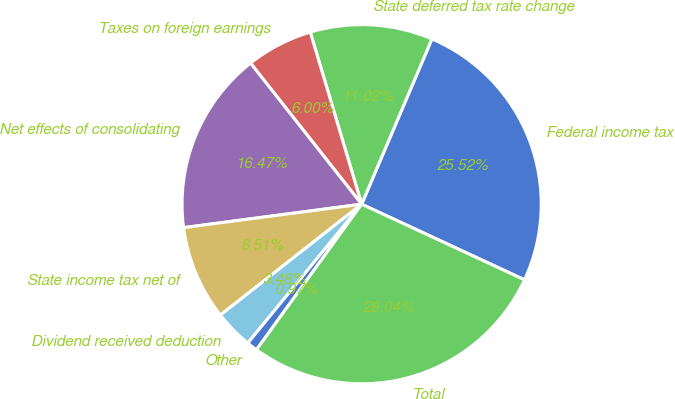Convert chart to OTSL. <chart><loc_0><loc_0><loc_500><loc_500><pie_chart><fcel>Federal income tax<fcel>State deferred tax rate change<fcel>Taxes on foreign earnings<fcel>Net effects of consolidating<fcel>State income tax net of<fcel>Dividend received deduction<fcel>Other<fcel>Total<nl><fcel>25.52%<fcel>11.02%<fcel>6.0%<fcel>16.47%<fcel>8.51%<fcel>3.48%<fcel>0.97%<fcel>28.04%<nl></chart> 